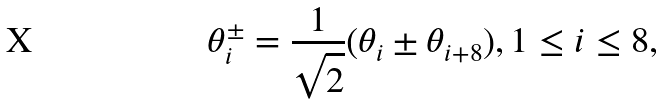<formula> <loc_0><loc_0><loc_500><loc_500>\theta _ { i } ^ { \pm } = \frac { 1 } { \sqrt { 2 } } ( \theta _ { i } \pm \theta _ { i + 8 } ) , 1 \leq i \leq 8 ,</formula> 